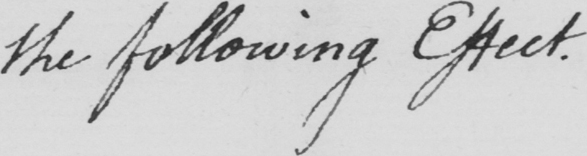What does this handwritten line say? the following Effect . 